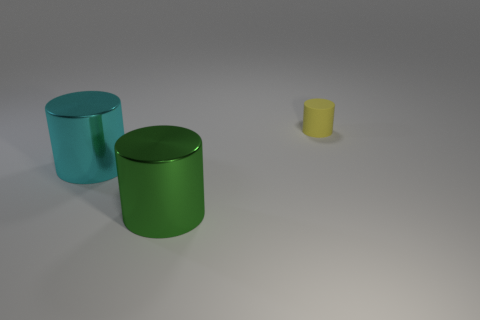What color is the tiny cylinder?
Your answer should be compact. Yellow. Is the number of big metallic objects greater than the number of blue rubber things?
Make the answer very short. Yes. How many objects are big metal cylinders that are on the right side of the big cyan object or shiny cylinders?
Provide a short and direct response. 2. Is the material of the green thing the same as the tiny thing?
Offer a terse response. No. There is a yellow rubber object that is the same shape as the green object; what size is it?
Make the answer very short. Small. Does the large shiny object right of the cyan object have the same shape as the thing behind the big cyan metal cylinder?
Keep it short and to the point. Yes. Does the yellow thing have the same size as the shiny cylinder that is behind the large green metallic thing?
Provide a succinct answer. No. What number of other objects are there of the same material as the green cylinder?
Keep it short and to the point. 1. Is there any other thing that has the same shape as the big cyan shiny thing?
Keep it short and to the point. Yes. There is a large metal cylinder behind the shiny cylinder on the right side of the large metal cylinder that is behind the large green metal object; what color is it?
Ensure brevity in your answer.  Cyan. 